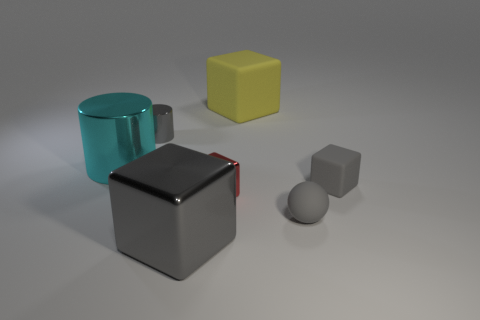Subtract all red cubes. How many cubes are left? 3 Subtract all big yellow blocks. How many blocks are left? 3 Subtract all purple blocks. Subtract all gray spheres. How many blocks are left? 4 Add 3 small red cubes. How many objects exist? 10 Subtract 0 purple cylinders. How many objects are left? 7 Subtract all cylinders. How many objects are left? 5 Subtract all big cylinders. Subtract all cyan shiny cylinders. How many objects are left? 5 Add 5 rubber things. How many rubber things are left? 8 Add 3 gray matte objects. How many gray matte objects exist? 5 